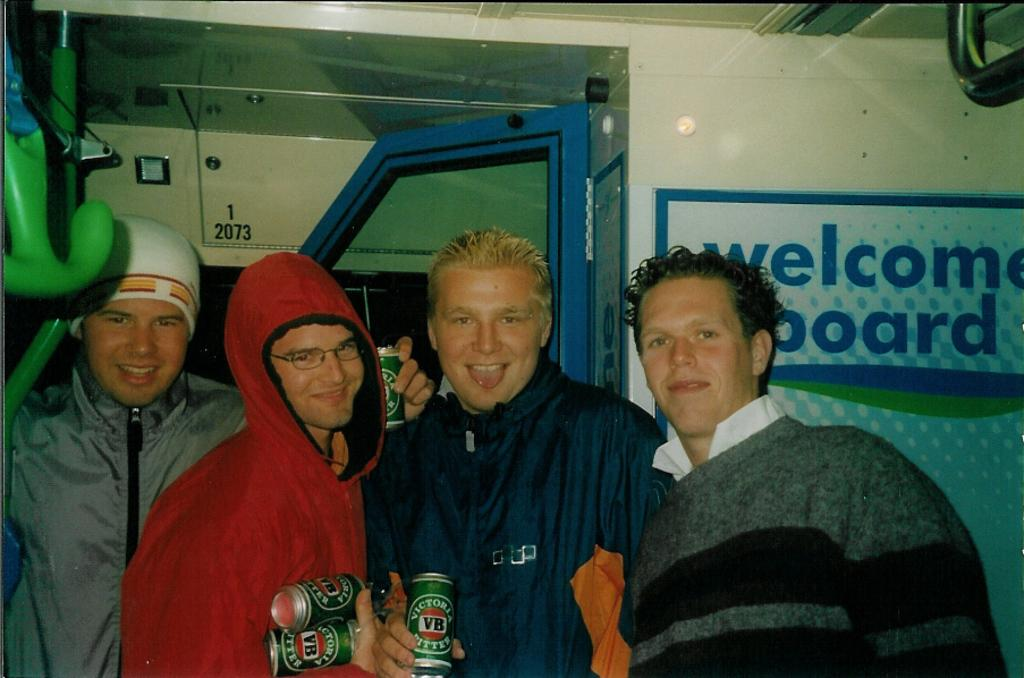How many people are in the image? There are four persons standing in the center of the image. What can be seen in the background of the image? There is a wall, a door, and a board in the background of the image. What is written or displayed on the board? There is text on the board, and there are other objects on the board as well. How many screws can be seen holding the board to the wall in the image? There is no information about screws in the image, as it only mentions the presence of a wall, a door, and a board with text and other objects. 